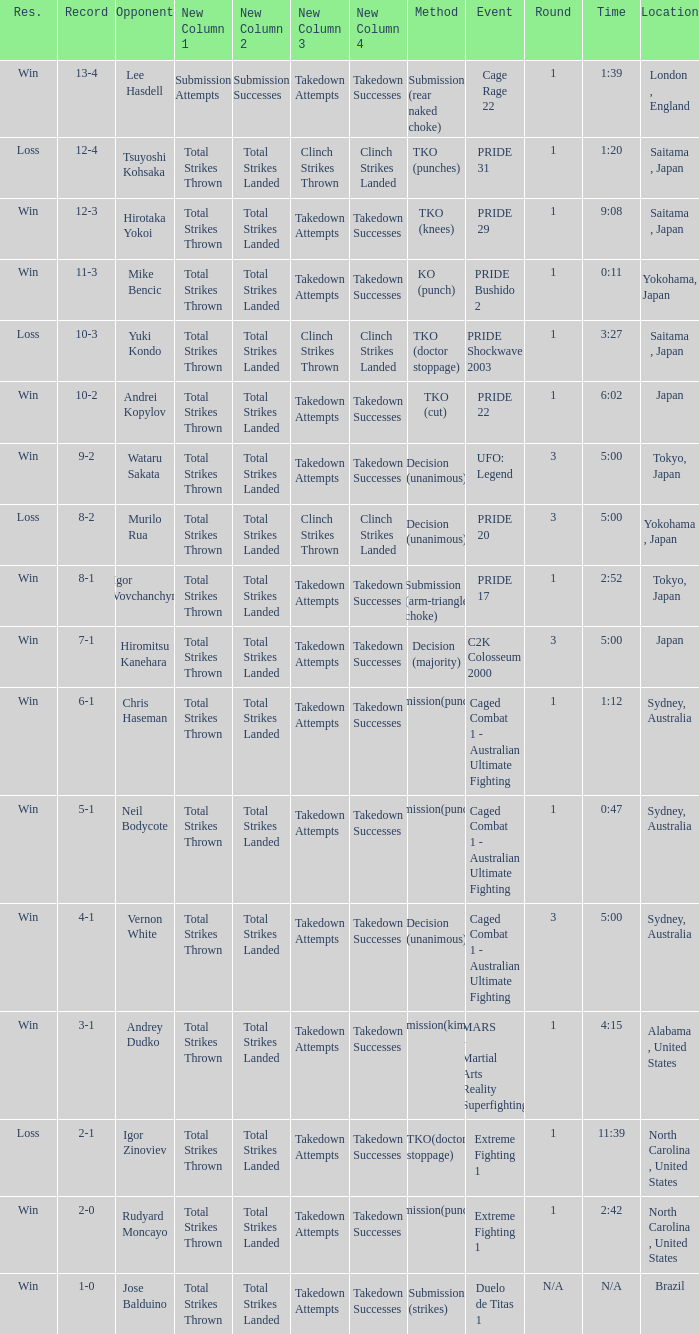Which Res has a Method of decision (unanimous) and an Opponent of Wataru Sakata? Win. 